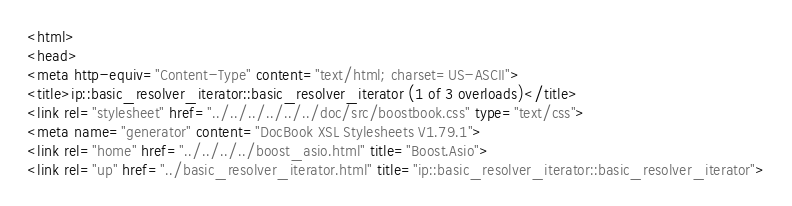<code> <loc_0><loc_0><loc_500><loc_500><_HTML_><html>
<head>
<meta http-equiv="Content-Type" content="text/html; charset=US-ASCII">
<title>ip::basic_resolver_iterator::basic_resolver_iterator (1 of 3 overloads)</title>
<link rel="stylesheet" href="../../../../../../doc/src/boostbook.css" type="text/css">
<meta name="generator" content="DocBook XSL Stylesheets V1.79.1">
<link rel="home" href="../../../../boost_asio.html" title="Boost.Asio">
<link rel="up" href="../basic_resolver_iterator.html" title="ip::basic_resolver_iterator::basic_resolver_iterator"></code> 